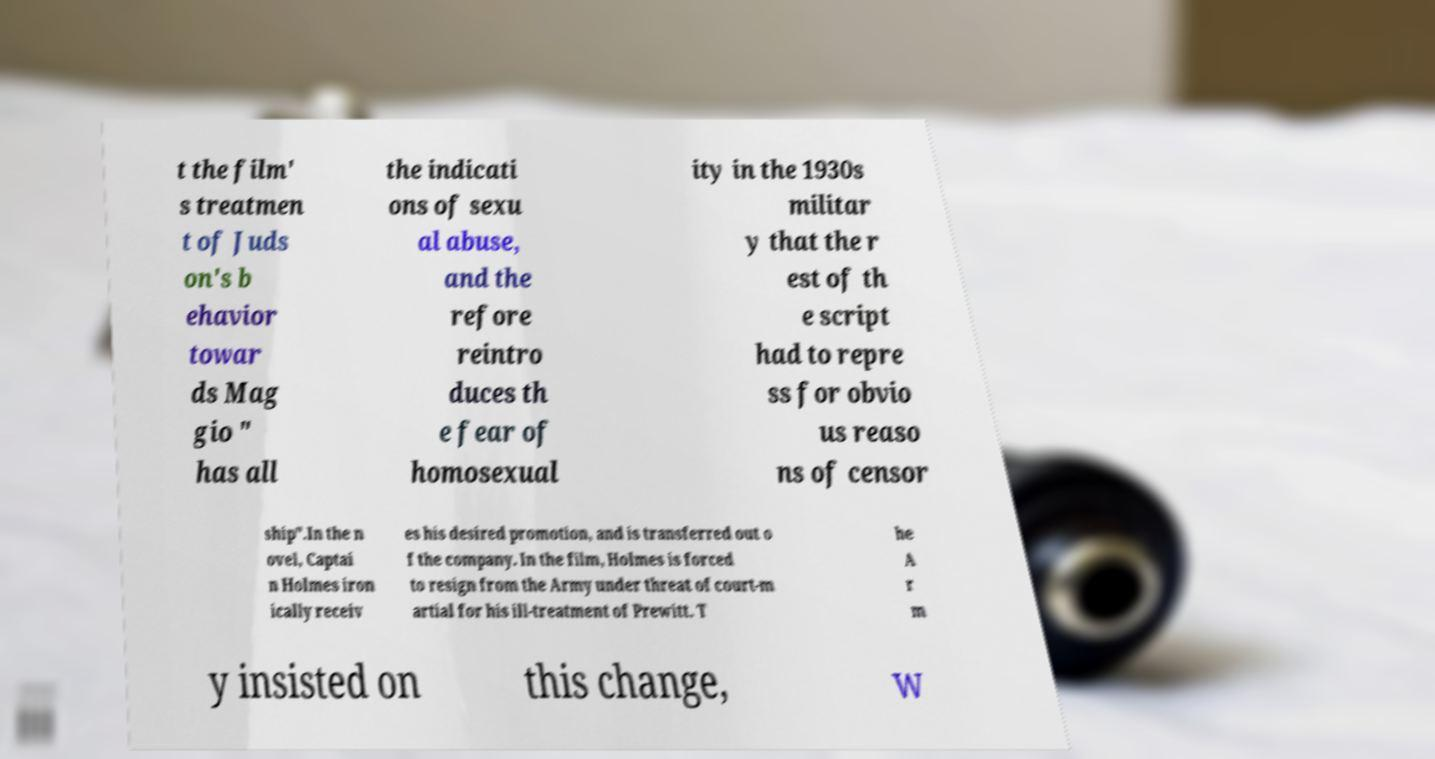What messages or text are displayed in this image? I need them in a readable, typed format. t the film' s treatmen t of Juds on's b ehavior towar ds Mag gio " has all the indicati ons of sexu al abuse, and the refore reintro duces th e fear of homosexual ity in the 1930s militar y that the r est of th e script had to repre ss for obvio us reaso ns of censor ship".In the n ovel, Captai n Holmes iron ically receiv es his desired promotion, and is transferred out o f the company. In the film, Holmes is forced to resign from the Army under threat of court-m artial for his ill-treatment of Prewitt. T he A r m y insisted on this change, w 